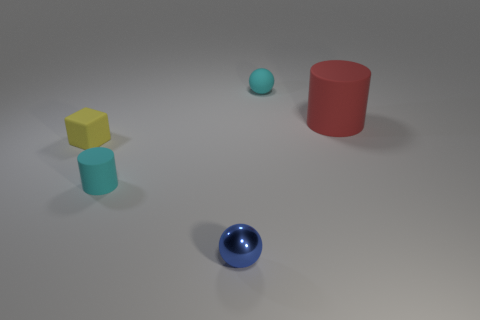Is there anything else that has the same material as the blue object?
Ensure brevity in your answer.  No. Are there any cyan things that have the same shape as the red rubber thing?
Ensure brevity in your answer.  Yes. How many things are spheres in front of the big red rubber cylinder or large purple rubber balls?
Make the answer very short. 1. Is the number of tiny blue things greater than the number of tiny objects?
Provide a short and direct response. No. Is there a red cylinder that has the same size as the cyan cylinder?
Provide a short and direct response. No. What number of objects are large red objects right of the small blue shiny sphere or small yellow rubber things that are left of the tiny cyan matte ball?
Ensure brevity in your answer.  2. What is the color of the rubber cylinder that is on the left side of the cylinder that is on the right side of the small blue ball?
Your response must be concise. Cyan. What is the color of the big cylinder that is made of the same material as the cyan sphere?
Your answer should be compact. Red. What number of tiny matte cylinders are the same color as the matte ball?
Offer a very short reply. 1. What number of objects are red cylinders or yellow rubber things?
Give a very brief answer. 2. 